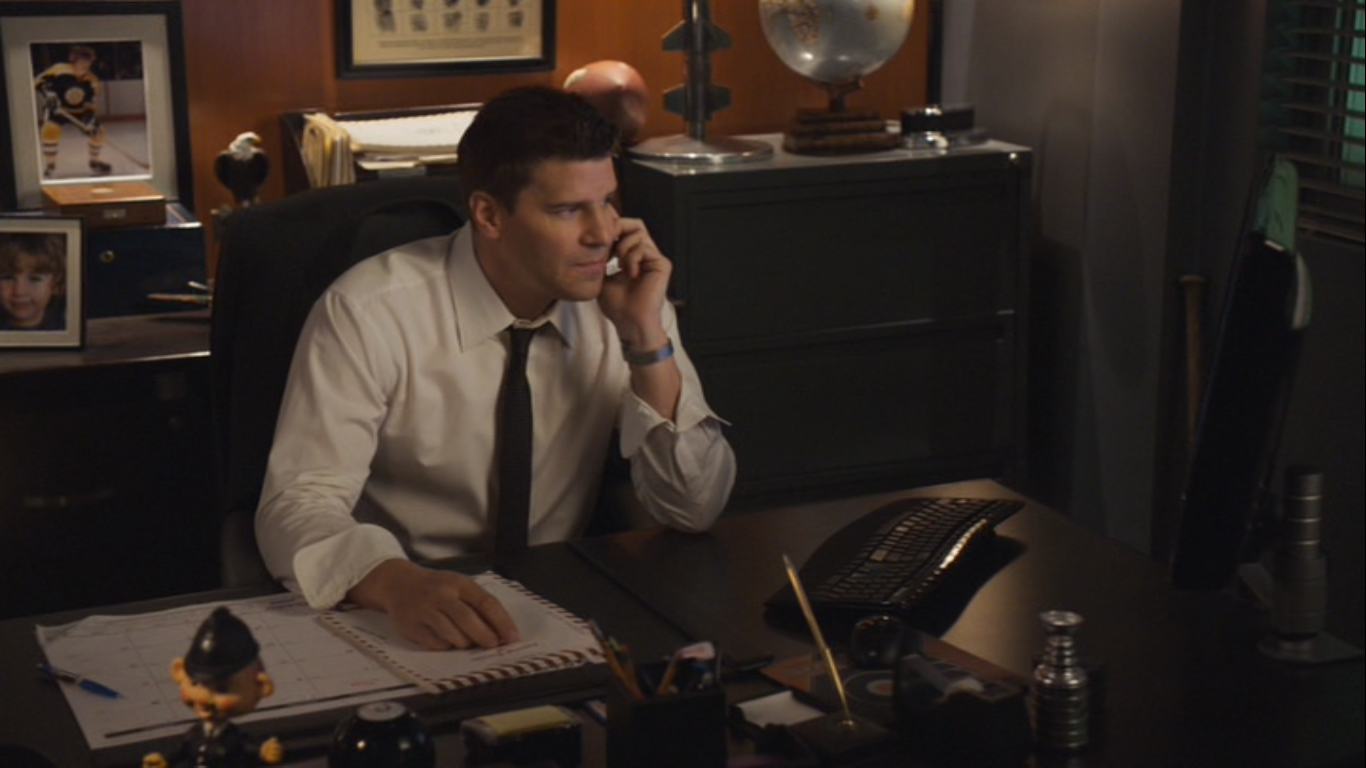What might be the significance of the globe and statue on the desk? The globe could represent a global perspective or interests related to travel, geography, or international affairs. The statue, on the other hand, might be a personal keepsake, a trophy of some sort, or an item with aesthetic or inspirational significance. Together, these objects may reveal the person's broader interests outside of their direct work responsibilities or serve as symbols of achievement and aspiration. 